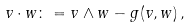<formula> <loc_0><loc_0><loc_500><loc_500>v \cdot w & \colon = v \wedge w - g ( v , w ) \, ,</formula> 